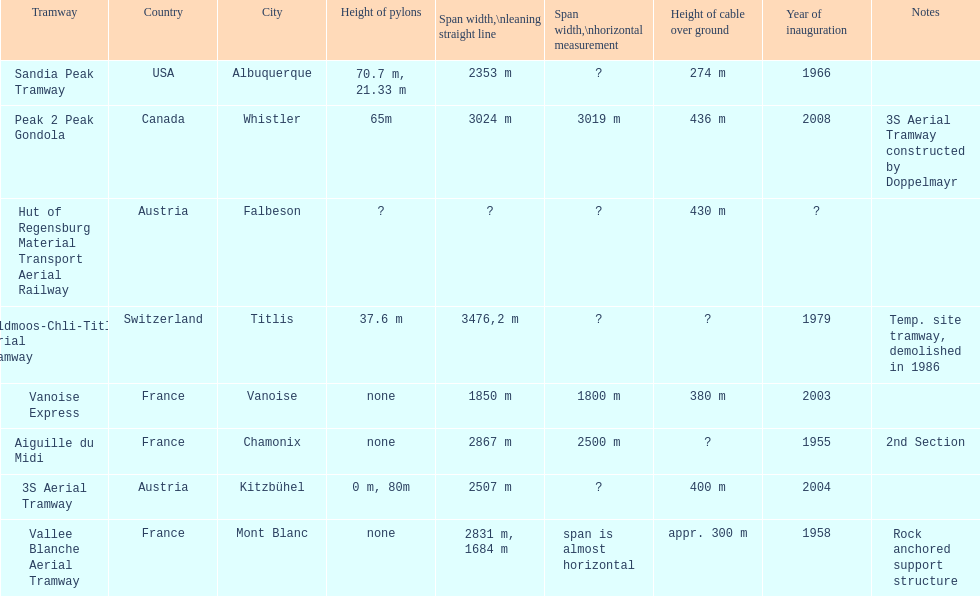Was the sandia peak tramway innagurate before or after the 3s aerial tramway? Before. 